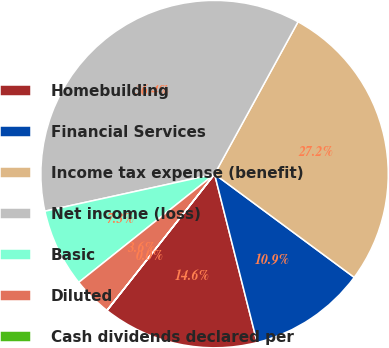<chart> <loc_0><loc_0><loc_500><loc_500><pie_chart><fcel>Homebuilding<fcel>Financial Services<fcel>Income tax expense (benefit)<fcel>Net income (loss)<fcel>Basic<fcel>Diluted<fcel>Cash dividends declared per<nl><fcel>14.57%<fcel>10.93%<fcel>27.16%<fcel>36.41%<fcel>7.29%<fcel>3.65%<fcel>0.01%<nl></chart> 